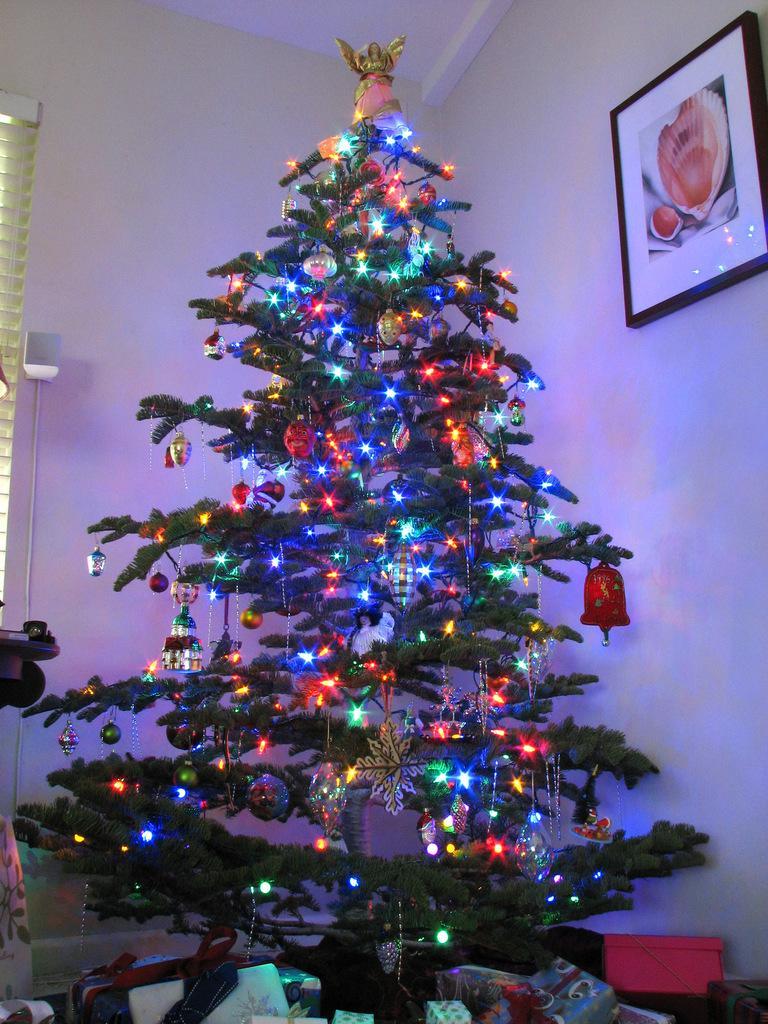Describe this image in one or two sentences. In this image I can see a christmas tree in the front. There are lights on the tree. There is a photo frame on the right. There is a window blind on the left. 